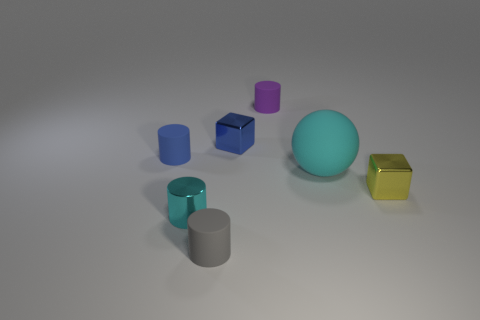Subtract all gray rubber cylinders. How many cylinders are left? 3 Add 1 purple matte things. How many objects exist? 8 Subtract 1 cylinders. How many cylinders are left? 3 Subtract all gray cylinders. How many cylinders are left? 3 Subtract all cyan cylinders. Subtract all purple balls. How many cylinders are left? 3 Subtract all balls. How many objects are left? 6 Add 5 tiny yellow things. How many tiny yellow things exist? 6 Subtract 1 blue blocks. How many objects are left? 6 Subtract all tiny blue cylinders. Subtract all small shiny things. How many objects are left? 3 Add 5 blue cylinders. How many blue cylinders are left? 6 